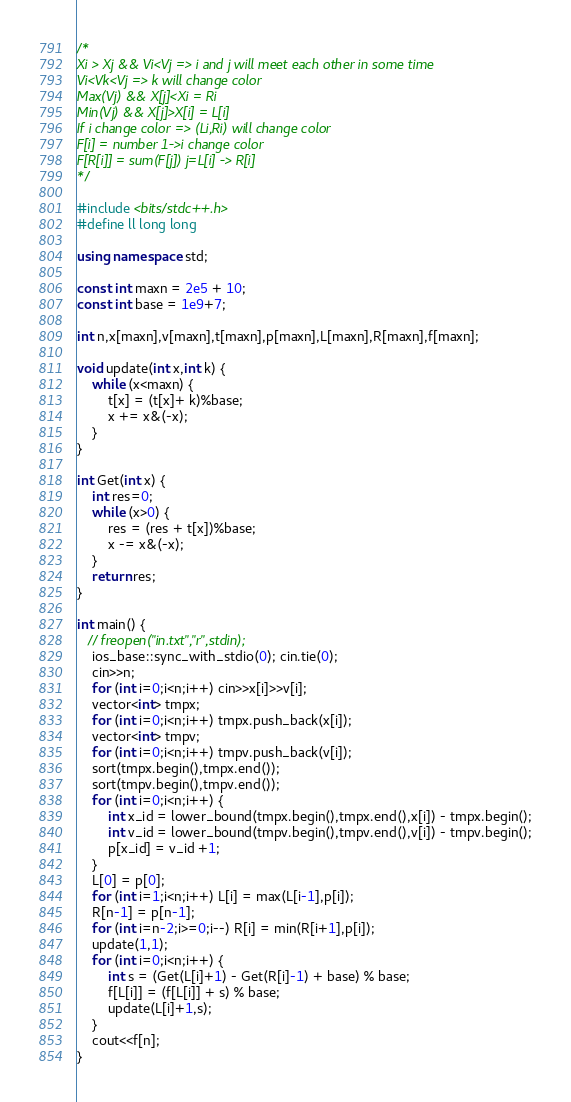<code> <loc_0><loc_0><loc_500><loc_500><_C++_>/*
Xi > Xj && Vi<Vj => i and j will meet each other in some time
Vi<Vk<Vj => k will change color
Max(Vj) && X[j]<Xi = Ri
Min(Vj) && X[j]>X[i] = L[i]
If i change color => (Li,Ri) will change color
F[i] = number 1->i change color
F[R[i]] = sum(F[j]) j=L[i] -> R[i]
*/

#include <bits/stdc++.h>
#define ll long long

using namespace std;

const int maxn = 2e5 + 10;
const int base = 1e9+7;

int n,x[maxn],v[maxn],t[maxn],p[maxn],L[maxn],R[maxn],f[maxn];

void update(int x,int k) {
    while (x<maxn) {
        t[x] = (t[x]+ k)%base;
        x += x&(-x);
    }
}

int Get(int x) {
    int res=0;
    while (x>0) {
        res = (res + t[x])%base;
        x -= x&(-x);
    }
    return res;
}

int main() {
   // freopen("in.txt","r",stdin);
    ios_base::sync_with_stdio(0); cin.tie(0);
    cin>>n;
    for (int i=0;i<n;i++) cin>>x[i]>>v[i];
    vector<int> tmpx;
    for (int i=0;i<n;i++) tmpx.push_back(x[i]);
    vector<int> tmpv;
    for (int i=0;i<n;i++) tmpv.push_back(v[i]);
    sort(tmpx.begin(),tmpx.end());
    sort(tmpv.begin(),tmpv.end());
    for (int i=0;i<n;i++) {
        int x_id = lower_bound(tmpx.begin(),tmpx.end(),x[i]) - tmpx.begin();
        int v_id = lower_bound(tmpv.begin(),tmpv.end(),v[i]) - tmpv.begin();
        p[x_id] = v_id +1;
    }
    L[0] = p[0];
    for (int i=1;i<n;i++) L[i] = max(L[i-1],p[i]);
    R[n-1] = p[n-1];
    for (int i=n-2;i>=0;i--) R[i] = min(R[i+1],p[i]);
    update(1,1);
    for (int i=0;i<n;i++) {
        int s = (Get(L[i]+1) - Get(R[i]-1) + base) % base;
        f[L[i]] = (f[L[i]] + s) % base;
        update(L[i]+1,s);
    }
    cout<<f[n];
}
</code> 